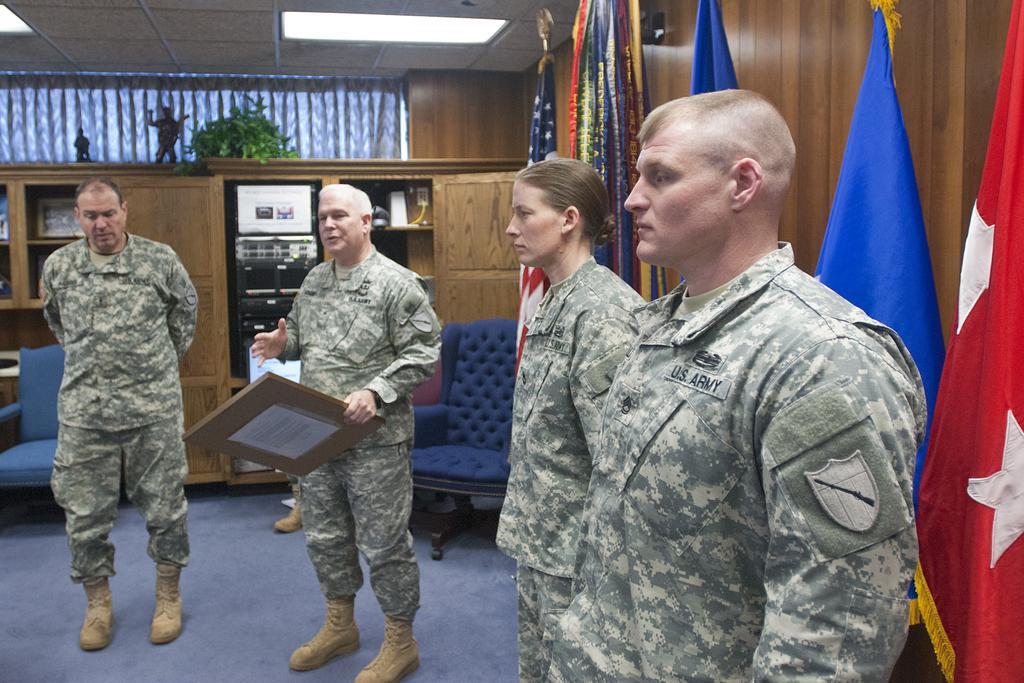Please provide a concise description of this image. In the center of the image we can see a man is standing and wearing a uniform, shoes and holding a board and talking. On the left side of the image we can see a man is standing and wearing a uniform, shoes. On the right side of the image we can see two people are standing and wearing the uniforms. In the background of the image we can see the cupboards, flags, wall, plant, toys, chairs. In the cupboards we can see the photo frames and some other objects. At the bottom of the image we can see the floor. At the top of the image we can see the curtain, roof and lights. 